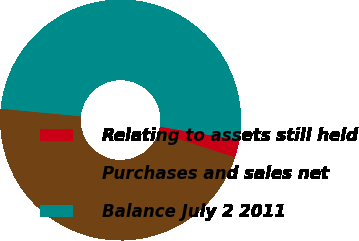Convert chart. <chart><loc_0><loc_0><loc_500><loc_500><pie_chart><fcel>Relating to assets still held<fcel>Purchases and sales net<fcel>Balance July 2 2011<nl><fcel>2.38%<fcel>46.49%<fcel>51.14%<nl></chart> 